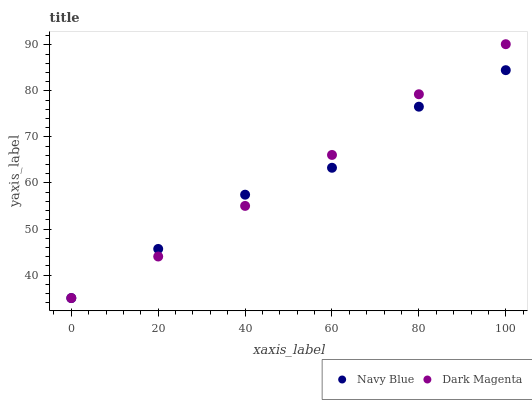Does Navy Blue have the minimum area under the curve?
Answer yes or no. Yes. Does Dark Magenta have the maximum area under the curve?
Answer yes or no. Yes. Does Dark Magenta have the minimum area under the curve?
Answer yes or no. No. Is Dark Magenta the smoothest?
Answer yes or no. Yes. Is Navy Blue the roughest?
Answer yes or no. Yes. Is Dark Magenta the roughest?
Answer yes or no. No. Does Navy Blue have the lowest value?
Answer yes or no. Yes. Does Dark Magenta have the highest value?
Answer yes or no. Yes. Does Navy Blue intersect Dark Magenta?
Answer yes or no. Yes. Is Navy Blue less than Dark Magenta?
Answer yes or no. No. Is Navy Blue greater than Dark Magenta?
Answer yes or no. No. 